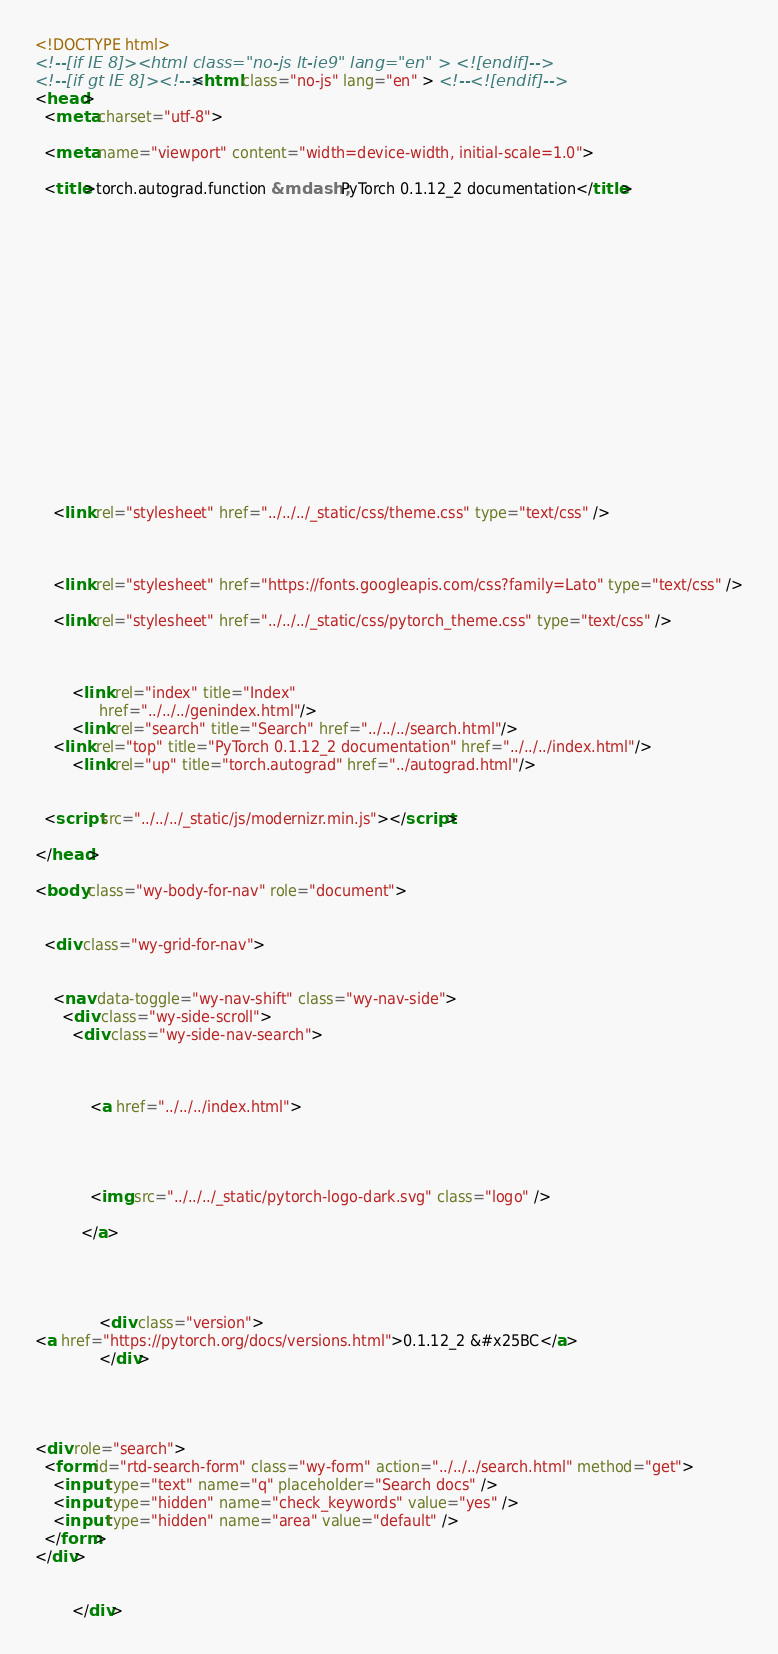Convert code to text. <code><loc_0><loc_0><loc_500><loc_500><_HTML_>

<!DOCTYPE html>
<!--[if IE 8]><html class="no-js lt-ie9" lang="en" > <![endif]-->
<!--[if gt IE 8]><!--> <html class="no-js" lang="en" > <!--<![endif]-->
<head>
  <meta charset="utf-8">
  
  <meta name="viewport" content="width=device-width, initial-scale=1.0">
  
  <title>torch.autograd.function &mdash; PyTorch 0.1.12_2 documentation</title>
  

  
  
  
  

  

  
  
    

  

  
  
    <link rel="stylesheet" href="../../../_static/css/theme.css" type="text/css" />
  

  
    <link rel="stylesheet" href="https://fonts.googleapis.com/css?family=Lato" type="text/css" />
  
    <link rel="stylesheet" href="../../../_static/css/pytorch_theme.css" type="text/css" />
  

  
        <link rel="index" title="Index"
              href="../../../genindex.html"/>
        <link rel="search" title="Search" href="../../../search.html"/>
    <link rel="top" title="PyTorch 0.1.12_2 documentation" href="../../../index.html"/>
        <link rel="up" title="torch.autograd" href="../autograd.html"/> 

  
  <script src="../../../_static/js/modernizr.min.js"></script>

</head>

<body class="wy-body-for-nav" role="document">

   
  <div class="wy-grid-for-nav">

    
    <nav data-toggle="wy-nav-shift" class="wy-nav-side">
      <div class="wy-side-scroll">
        <div class="wy-side-nav-search">
          

          
            <a href="../../../index.html">
          

          
            
            <img src="../../../_static/pytorch-logo-dark.svg" class="logo" />
          
          </a>

          
            
            
              <div class="version">
<a href="https://pytorch.org/docs/versions.html">0.1.12_2 &#x25BC</a>                
              </div>
            
          

          
<div role="search">
  <form id="rtd-search-form" class="wy-form" action="../../../search.html" method="get">
    <input type="text" name="q" placeholder="Search docs" />
    <input type="hidden" name="check_keywords" value="yes" />
    <input type="hidden" name="area" value="default" />
  </form>
</div>

          
        </div>
</code> 